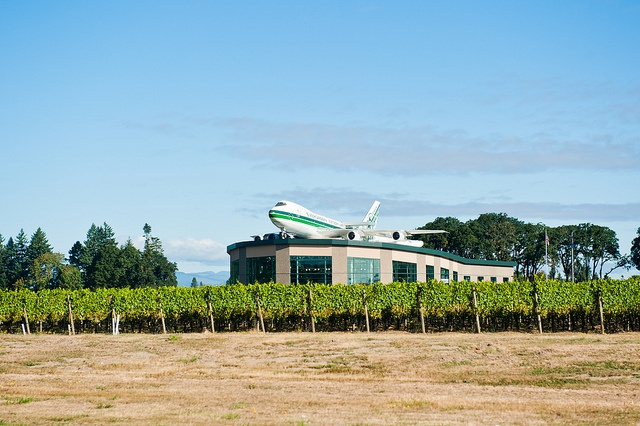Describe the objects in this image and their specific colors. I can see a airplane in lightblue, white, darkgray, black, and gray tones in this image. 